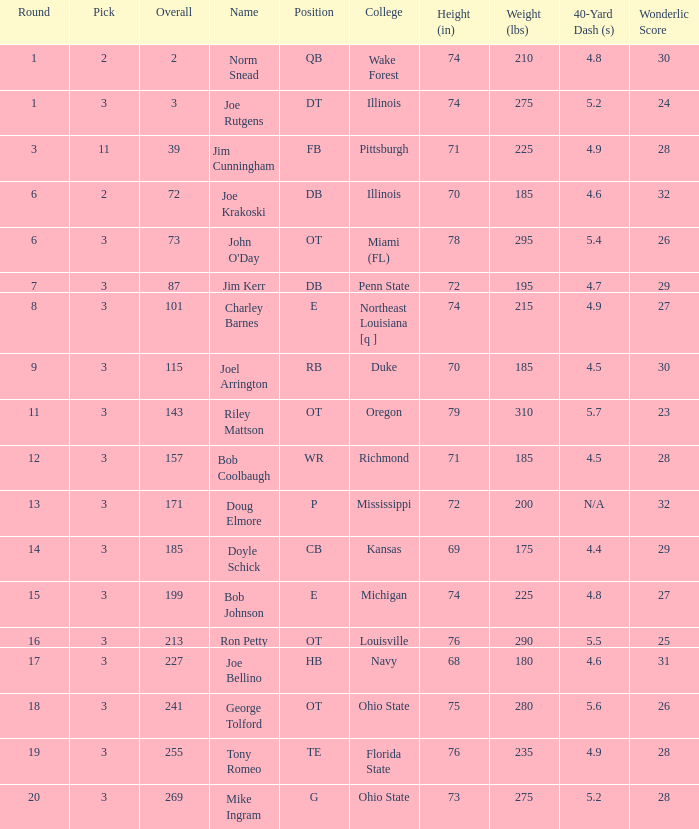How many overalls have charley barnes as the name, with a pick less than 3? None. I'm looking to parse the entire table for insights. Could you assist me with that? {'header': ['Round', 'Pick', 'Overall', 'Name', 'Position', 'College', 'Height (in)', 'Weight (lbs)', '40-Yard Dash (s)', 'Wonderlic Score'], 'rows': [['1', '2', '2', 'Norm Snead', 'QB', 'Wake Forest', '74', '210', '4.8', '30'], ['1', '3', '3', 'Joe Rutgens', 'DT', 'Illinois', '74', '275', '5.2', '24'], ['3', '11', '39', 'Jim Cunningham', 'FB', 'Pittsburgh', '71', '225', '4.9', '28'], ['6', '2', '72', 'Joe Krakoski', 'DB', 'Illinois', '70', '185', '4.6', '32'], ['6', '3', '73', "John O'Day", 'OT', 'Miami (FL)', '78', '295', '5.4', '26'], ['7', '3', '87', 'Jim Kerr', 'DB', 'Penn State', '72', '195', '4.7', '29'], ['8', '3', '101', 'Charley Barnes', 'E', 'Northeast Louisiana [q ]', '74', '215', '4.9', '27'], ['9', '3', '115', 'Joel Arrington', 'RB', 'Duke', '70', '185', '4.5', '30'], ['11', '3', '143', 'Riley Mattson', 'OT', 'Oregon', '79', '310', '5.7', '23'], ['12', '3', '157', 'Bob Coolbaugh', 'WR', 'Richmond', '71', '185', '4.5', '28'], ['13', '3', '171', 'Doug Elmore', 'P', 'Mississippi', '72', '200', 'N/A', '32'], ['14', '3', '185', 'Doyle Schick', 'CB', 'Kansas', '69', '175', '4.4', '29'], ['15', '3', '199', 'Bob Johnson', 'E', 'Michigan', '74', '225', '4.8', '27'], ['16', '3', '213', 'Ron Petty', 'OT', 'Louisville', '76', '290', '5.5', '25'], ['17', '3', '227', 'Joe Bellino', 'HB', 'Navy', '68', '180', '4.6', '31'], ['18', '3', '241', 'George Tolford', 'OT', 'Ohio State', '75', '280', '5.6', '26'], ['19', '3', '255', 'Tony Romeo', 'TE', 'Florida State', '76', '235', '4.9', '28'], ['20', '3', '269', 'Mike Ingram', 'G', 'Ohio State', '73', '275', '5.2', '28']]} 